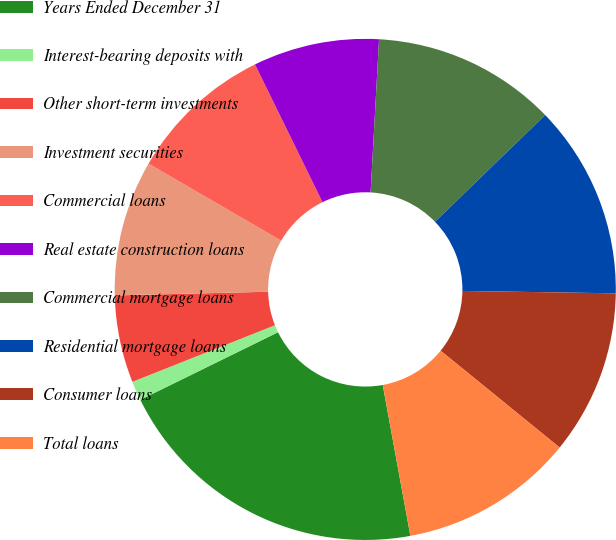Convert chart. <chart><loc_0><loc_0><loc_500><loc_500><pie_chart><fcel>Years Ended December 31<fcel>Interest-bearing deposits with<fcel>Other short-term investments<fcel>Investment securities<fcel>Commercial loans<fcel>Real estate construction loans<fcel>Commercial mortgage loans<fcel>Residential mortgage loans<fcel>Consumer loans<fcel>Total loans<nl><fcel>20.62%<fcel>1.25%<fcel>5.63%<fcel>8.75%<fcel>9.38%<fcel>8.13%<fcel>11.87%<fcel>12.5%<fcel>10.62%<fcel>11.25%<nl></chart> 